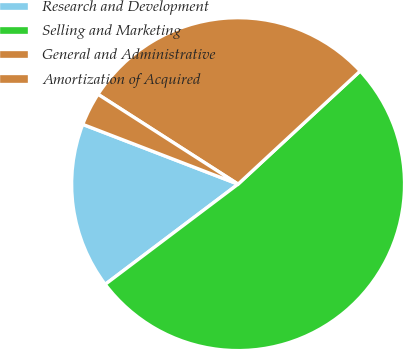Convert chart. <chart><loc_0><loc_0><loc_500><loc_500><pie_chart><fcel>Research and Development<fcel>Selling and Marketing<fcel>General and Administrative<fcel>Amortization of Acquired<nl><fcel>16.13%<fcel>51.61%<fcel>29.03%<fcel>3.23%<nl></chart> 